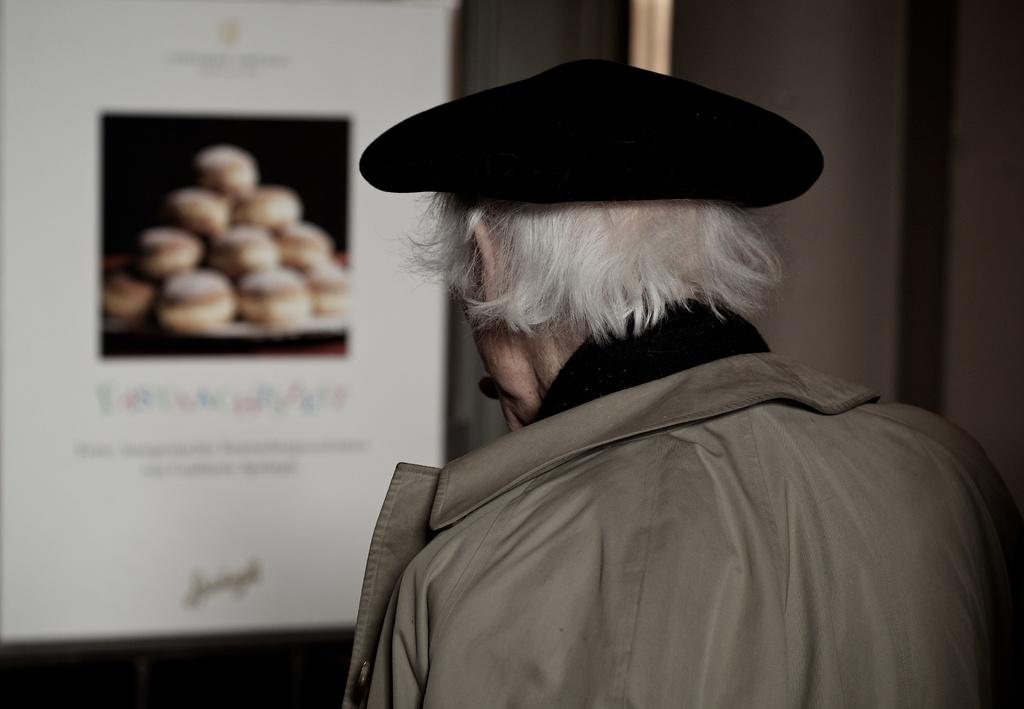Who is the main subject in the image? There is an old man in the image. What is the old man wearing? The old man is wearing a coat and a cap. What is the old man looking at in the image? The old man is looking at a poster. What is depicted on the poster? The poster contains cupcakes and text. Where is the poster located in relation to the old man? The poster is in front of the old man. What type of wilderness can be seen in the background of the image? There is no wilderness visible in the image; it is focused on the old man and the poster in front of him. How many family members are present in the image? There is no family present in the image; it only features the old man and the poster. 